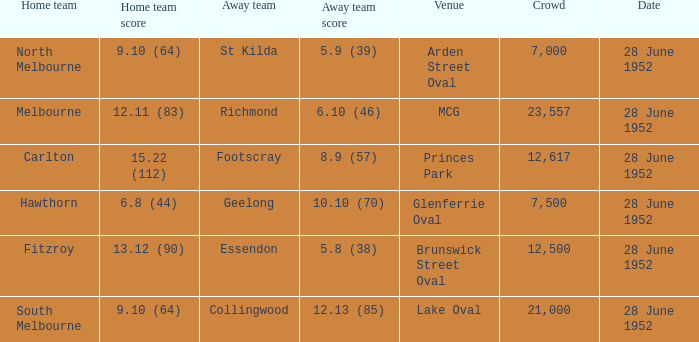Who is the away side when north melbourne is at home and has a score of 9.10 (64)? St Kilda. 